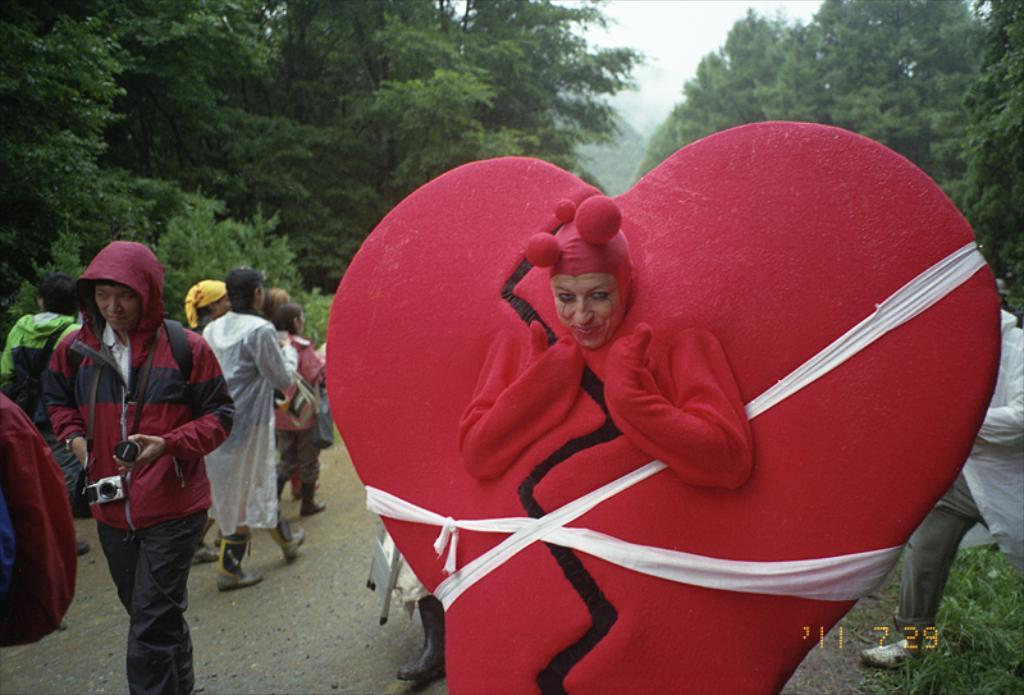What is happening on the road in the image? There are people on the road in the image. What type of vegetation is on the right side of the image? There is grass on the right side of the image. What can be seen in the background of the image? There are trees and the sky visible in the background of the image. What type of salt is being used by the actor in the image? There is no actor or salt present in the image. What is the source of the surprise in the image? There is no surprise depicted in the image. 